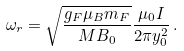<formula> <loc_0><loc_0><loc_500><loc_500>\omega _ { r } = \sqrt { \frac { g _ { F } \mu _ { B } m _ { F } } { M B _ { 0 } } } \frac { \mu _ { 0 } I } { 2 \pi y _ { 0 } ^ { 2 } } \, .</formula> 